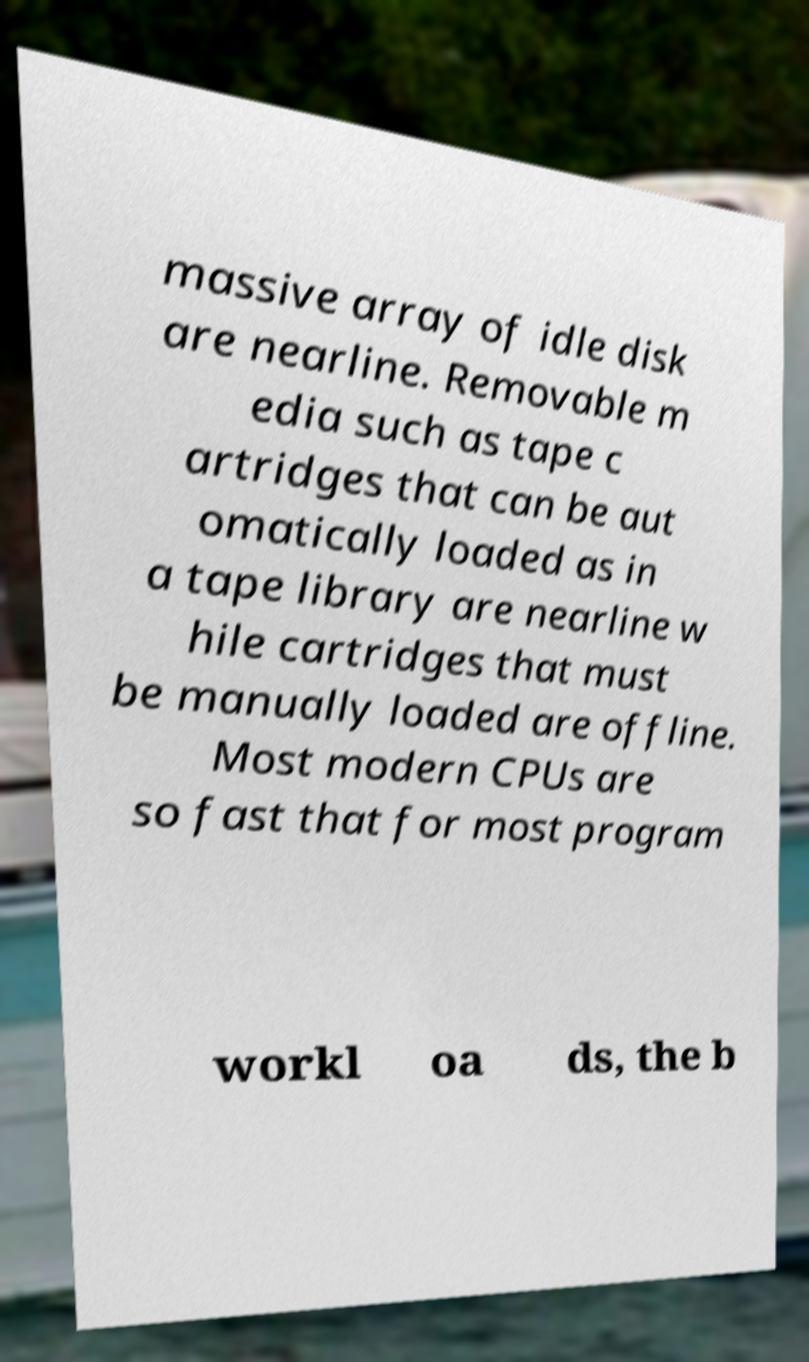For documentation purposes, I need the text within this image transcribed. Could you provide that? massive array of idle disk are nearline. Removable m edia such as tape c artridges that can be aut omatically loaded as in a tape library are nearline w hile cartridges that must be manually loaded are offline. Most modern CPUs are so fast that for most program workl oa ds, the b 